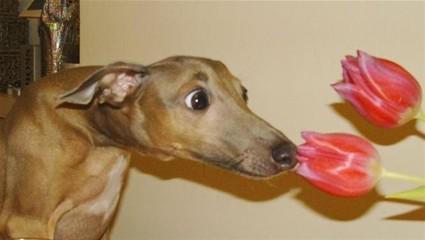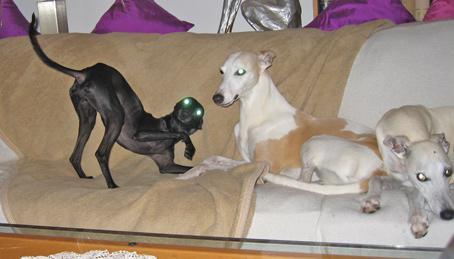The first image is the image on the left, the second image is the image on the right. For the images displayed, is the sentence "One of the images shows a brown dog with a ball in its mouth." factually correct? Answer yes or no. No. The first image is the image on the left, the second image is the image on the right. Considering the images on both sides, is "All dogs are sleeping." valid? Answer yes or no. No. 